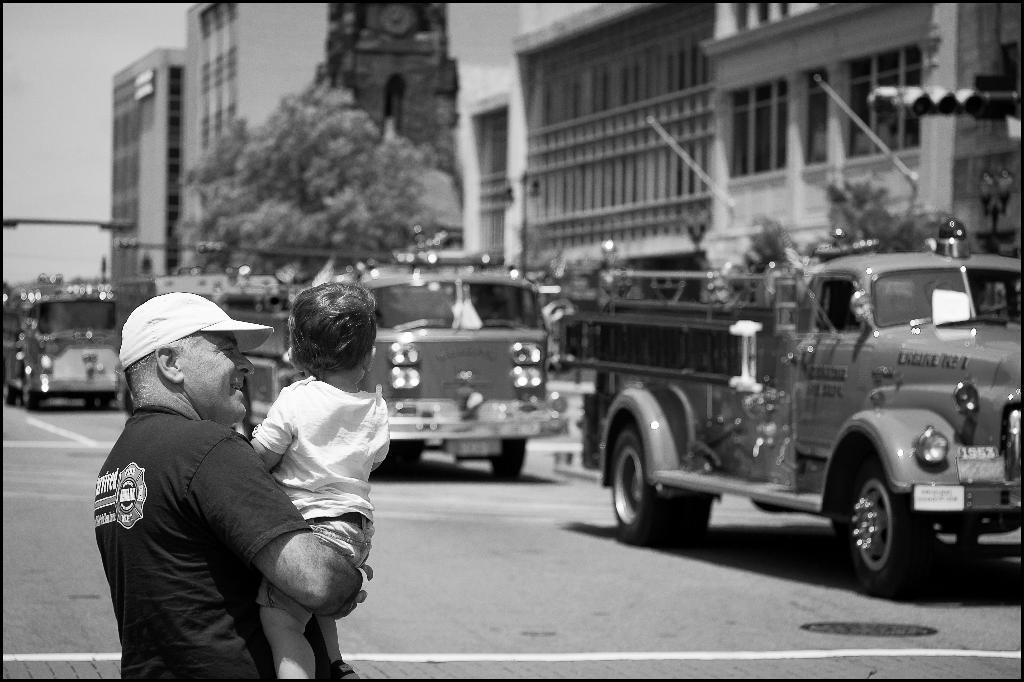What is the person in the image doing with the kid? The person is standing and holding a kid in the image. What can be seen on the road in the image? There are vehicles on the road in the image. What type of structures are visible in the image? There are buildings in the image. What type of vegetation is present in the image? There is a tree in the image. What type of man-made structures are present in the image? There is a light pole and a street light in the image. What part of the natural environment is visible in the image? The sky is visible in the image. Can you tell me how many twigs are being used as a walking stick by the person in the image? There is no twig present in the image, and the person is not using a walking stick. What type of trouble is the person in the image experiencing with the kid? There is no indication of trouble in the image; the person is simply holding the kid. 